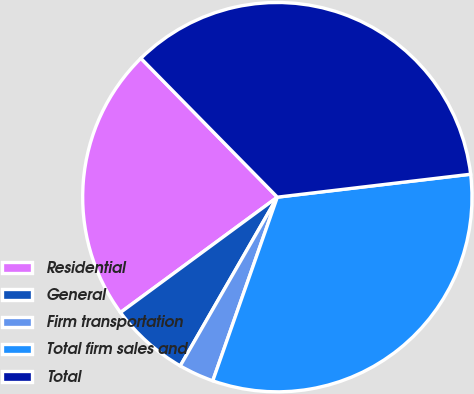Convert chart to OTSL. <chart><loc_0><loc_0><loc_500><loc_500><pie_chart><fcel>Residential<fcel>General<fcel>Firm transportation<fcel>Total firm sales and<fcel>Total<nl><fcel>22.73%<fcel>6.6%<fcel>2.93%<fcel>32.26%<fcel>35.48%<nl></chart> 